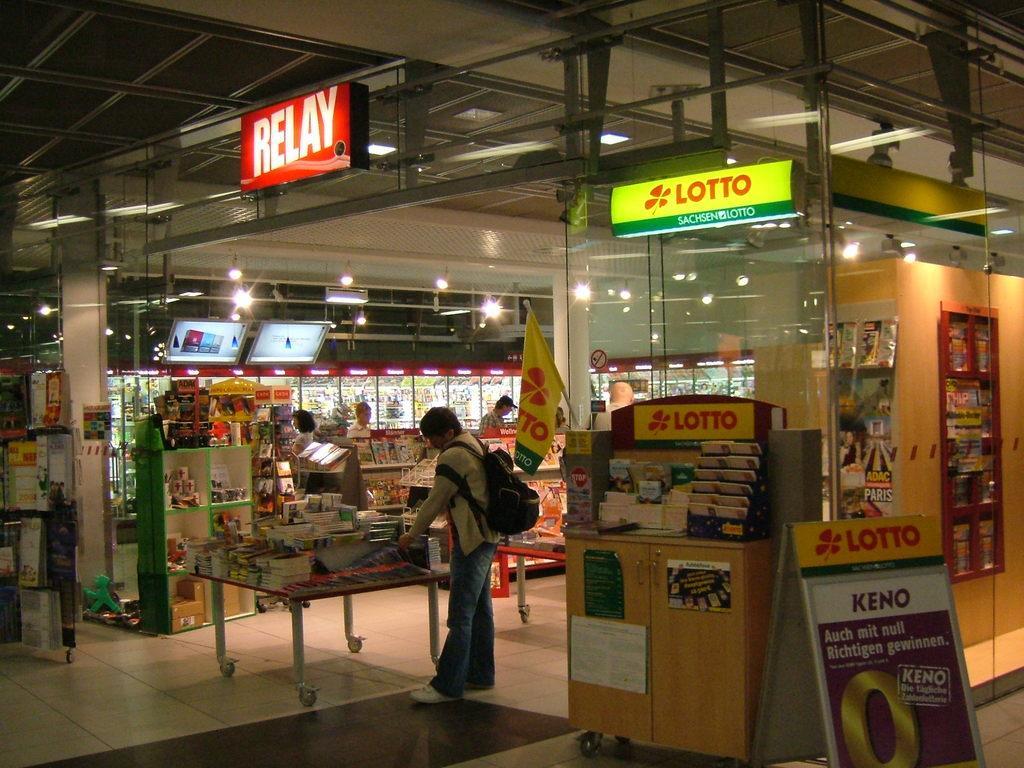How would you summarize this image in a sentence or two? In the image we can see a store and a table on the table there are many other things kept. There are even people standing, wearing clothes and this person is wearing shoes and carrying a bag on his back. Here we can see a floor, led board, lights and a poster. 